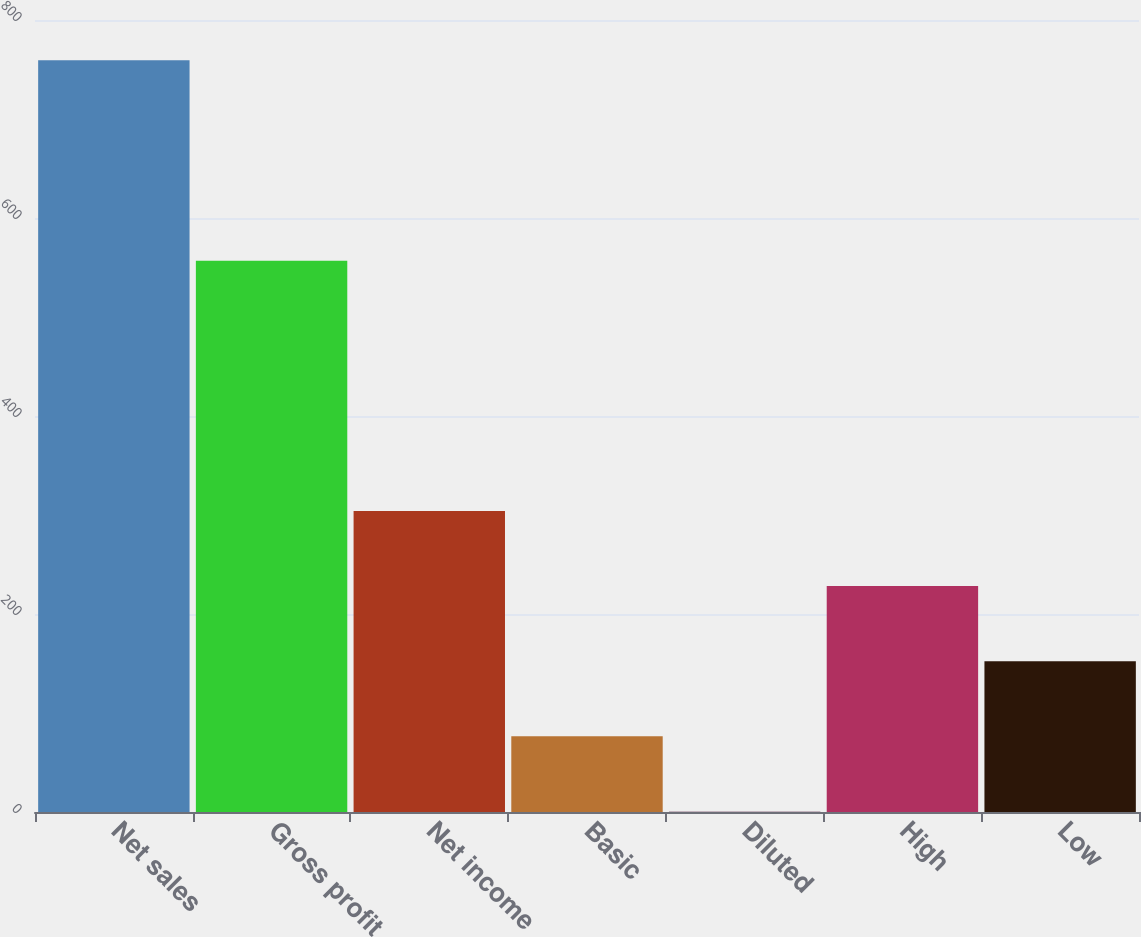Convert chart. <chart><loc_0><loc_0><loc_500><loc_500><bar_chart><fcel>Net sales<fcel>Gross profit<fcel>Net income<fcel>Basic<fcel>Diluted<fcel>High<fcel>Low<nl><fcel>759.3<fcel>556.8<fcel>304.06<fcel>76.45<fcel>0.58<fcel>228.19<fcel>152.32<nl></chart> 